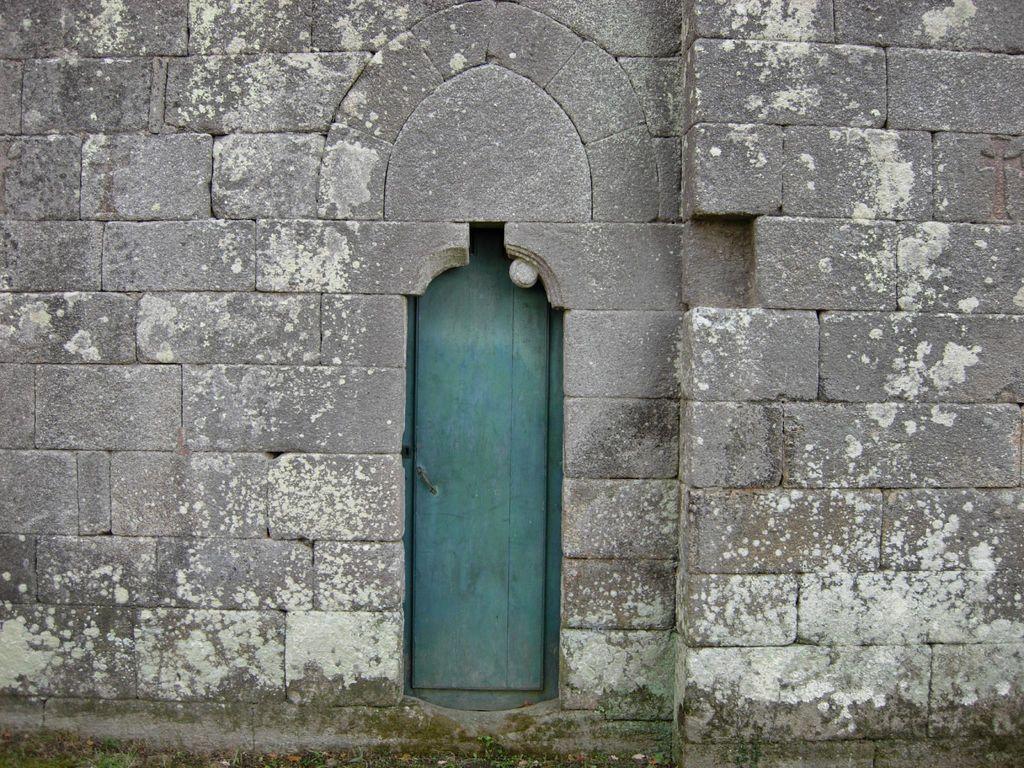How would you summarize this image in a sentence or two? In this picture we can see a door and a wall. 